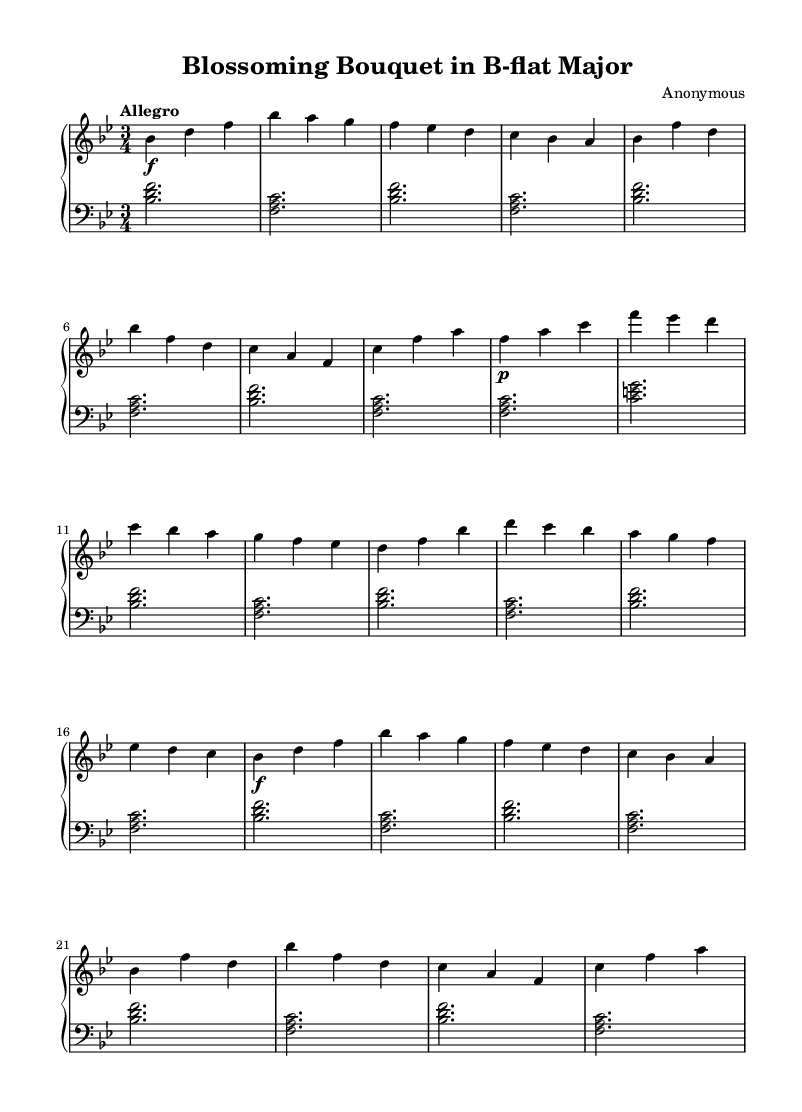What is the key signature of this music? The key signature is B-flat major, which has two flats (B-flat and E-flat). This can be seen at the beginning of the staff.
Answer: B-flat major What is the time signature of this piece? The time signature is 3/4, indicating there are three beats in each measure and the quarter note gets one beat. This is indicated at the beginning of the notation.
Answer: 3/4 What is the indicated tempo marking? The indicated tempo marking is "Allegro," which suggests a brisk and lively pace for the performance. This can be found at the top of the sheet music beneath the title.
Answer: Allegro Which section of the piece is marked to be played softly? The B section is marked to be played softly, as indicated by the "p" (piano) marking before the first note in that section.
Answer: Piano How many sections are there in this piece? The piece consists of two sections: labeled A and B. The structure is repeated, but only the A and B labels indicate the primary sections clearly.
Answer: Two What could be described as the main theme in the A section? The main theme in the A section features the melody primarily centered around the notes B-flat, D, and F, which are repeatedly played in various combinations throughout the section.
Answer: B-flat, D, F What stylistic characteristic is evident in this Baroque piece? A stylistic characteristic evident in this piece is the use of ornamentation, which is common in Baroque music. This can be inferred from the melodic structure and the frequent use of arpeggios.
Answer: Ornamentation 